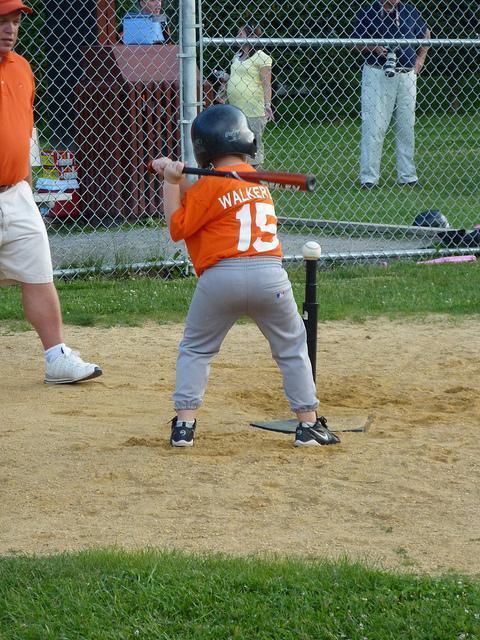How many shirts is the boy wearing?
Give a very brief answer. 1. How many people are holding bats?
Give a very brief answer. 1. How many people are there?
Give a very brief answer. 4. 